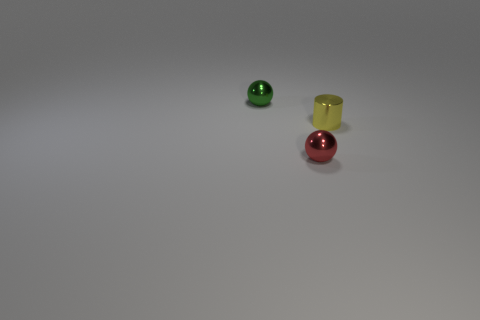There is another ball that is the same material as the red ball; what color is it? The ball that shares the same glossy material as the red ball is green in color. 